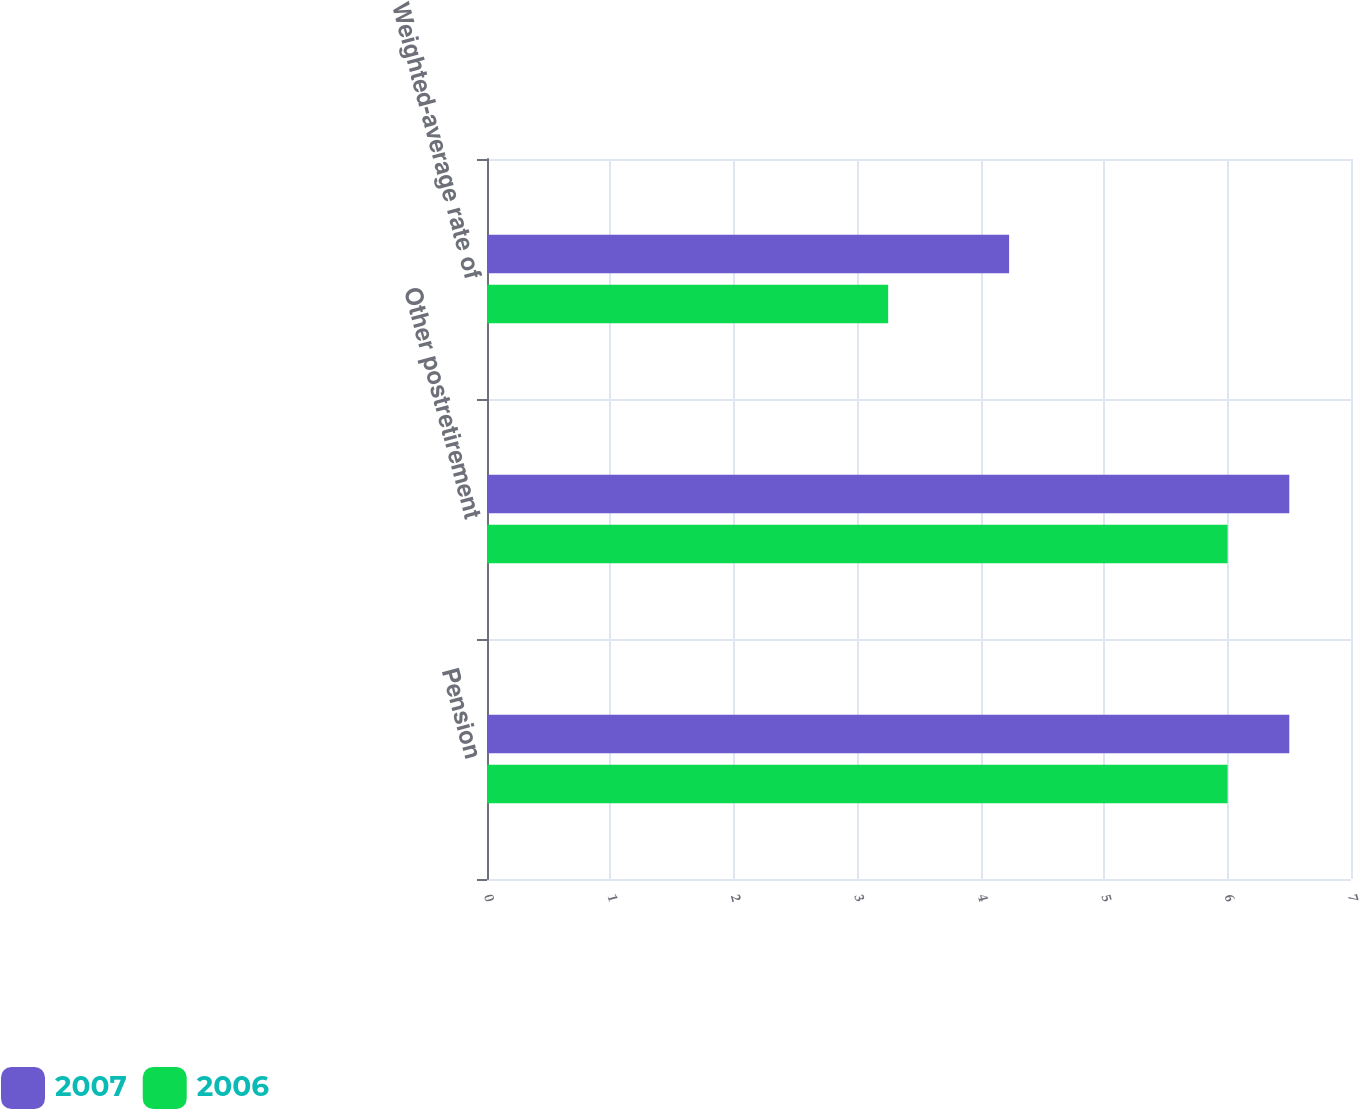<chart> <loc_0><loc_0><loc_500><loc_500><stacked_bar_chart><ecel><fcel>Pension<fcel>Other postretirement<fcel>Weighted-average rate of<nl><fcel>2007<fcel>6.5<fcel>6.5<fcel>4.23<nl><fcel>2006<fcel>6<fcel>6<fcel>3.25<nl></chart> 